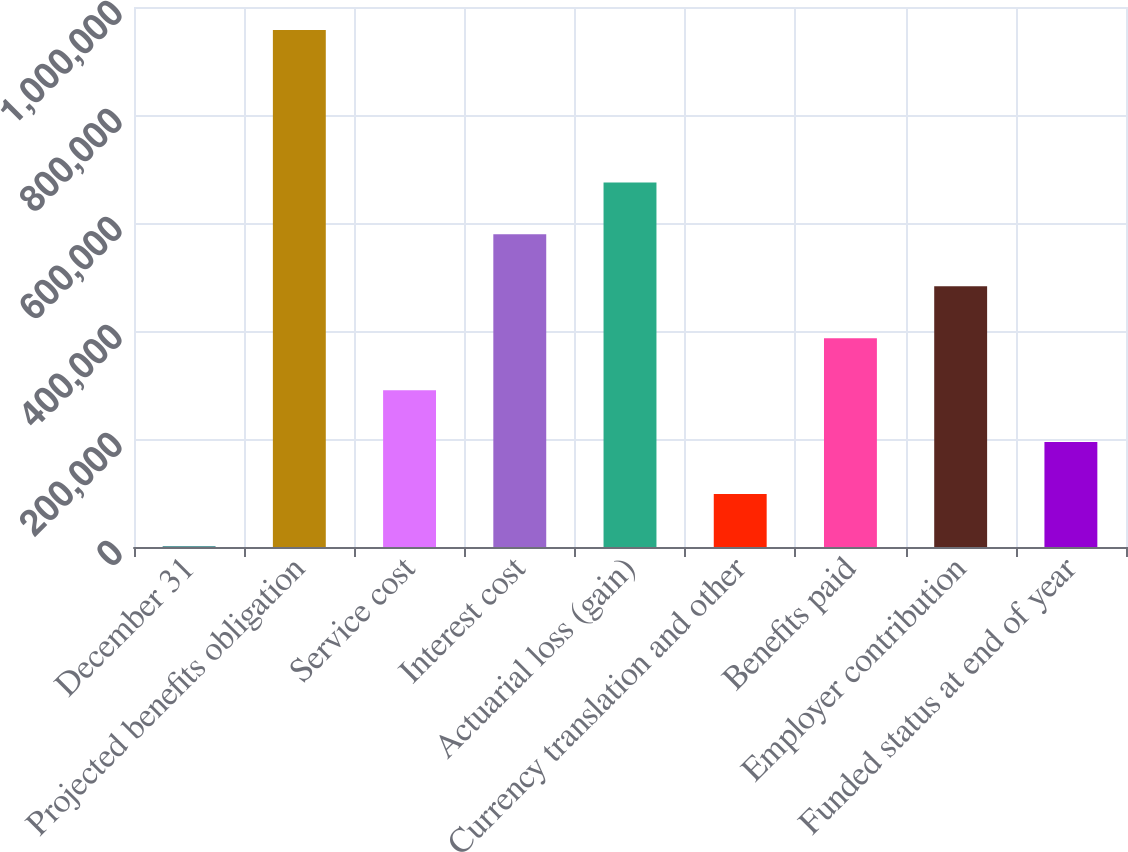<chart> <loc_0><loc_0><loc_500><loc_500><bar_chart><fcel>December 31<fcel>Projected benefits obligation<fcel>Service cost<fcel>Interest cost<fcel>Actuarial loss (gain)<fcel>Currency translation and other<fcel>Benefits paid<fcel>Employer contribution<fcel>Funded status at end of year<nl><fcel>2009<fcel>957538<fcel>290485<fcel>578962<fcel>675121<fcel>98167.8<fcel>386644<fcel>482803<fcel>194327<nl></chart> 